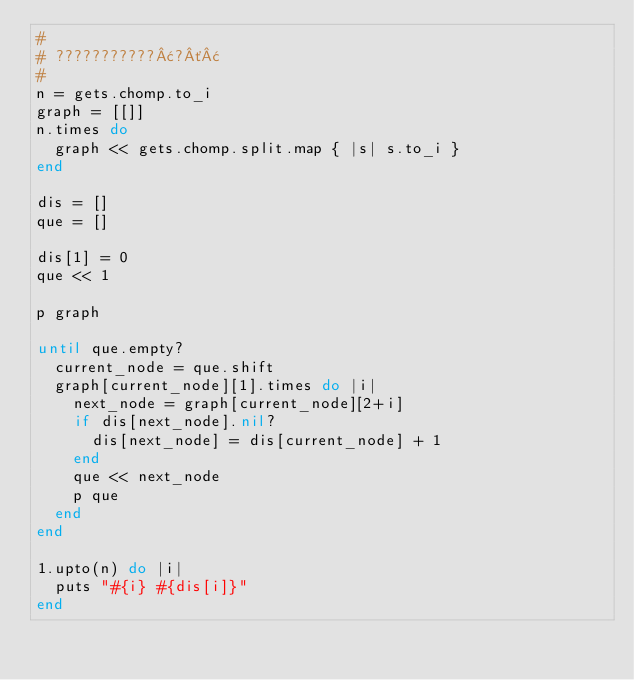<code> <loc_0><loc_0><loc_500><loc_500><_Ruby_>#
# ???????????¢?´¢
#
n = gets.chomp.to_i
graph = [[]]
n.times do
  graph << gets.chomp.split.map { |s| s.to_i }
end

dis = []
que = []

dis[1] = 0
que << 1

p graph

until que.empty?
  current_node = que.shift
  graph[current_node][1].times do |i|
    next_node = graph[current_node][2+i]
    if dis[next_node].nil? 
      dis[next_node] = dis[current_node] + 1
    end
    que << next_node
    p que
  end
end

1.upto(n) do |i|
  puts "#{i} #{dis[i]}"
end</code> 